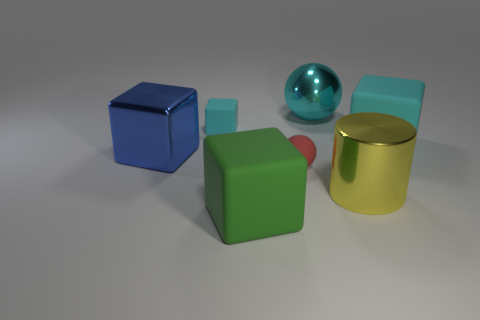Subtract all brown spheres. Subtract all purple cubes. How many spheres are left? 2 Add 1 big blue shiny objects. How many objects exist? 8 Subtract all balls. How many objects are left? 5 Subtract 1 green blocks. How many objects are left? 6 Subtract all red matte balls. Subtract all metallic cylinders. How many objects are left? 5 Add 2 blocks. How many blocks are left? 6 Add 5 cubes. How many cubes exist? 9 